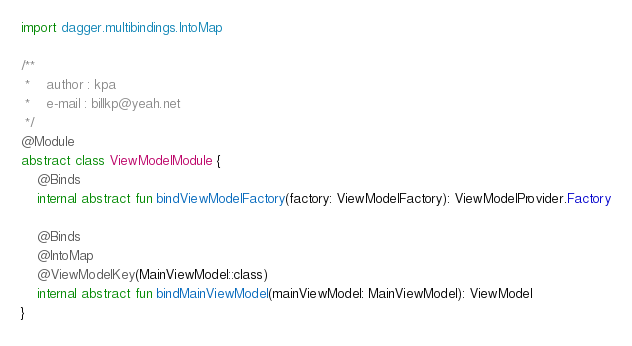Convert code to text. <code><loc_0><loc_0><loc_500><loc_500><_Kotlin_>import dagger.multibindings.IntoMap

/**
 *    author : kpa
 *    e-mail : billkp@yeah.net
 */
@Module
abstract class ViewModelModule {
    @Binds
    internal abstract fun bindViewModelFactory(factory: ViewModelFactory): ViewModelProvider.Factory

    @Binds
    @IntoMap
    @ViewModelKey(MainViewModel::class)
    internal abstract fun bindMainViewModel(mainViewModel: MainViewModel): ViewModel
}</code> 